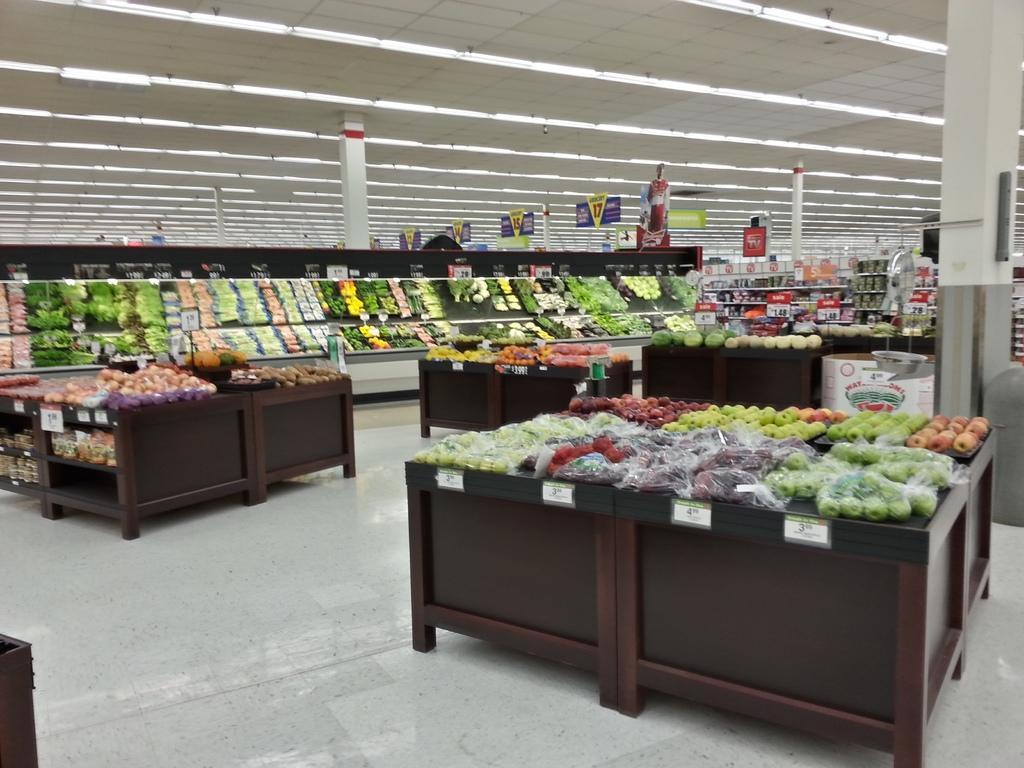Describe this image in one or two sentences. In the image we can see the vegetables and fruits store and they are kept on the shelf and on the table. Here we can see floor, pillar, poster and the lights. 